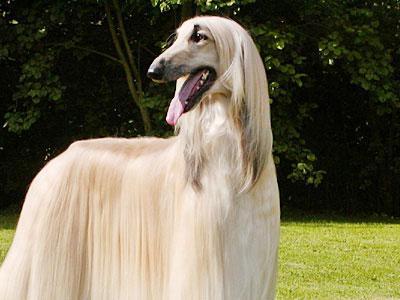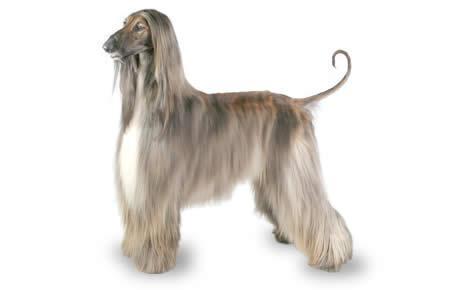The first image is the image on the left, the second image is the image on the right. Analyze the images presented: Is the assertion "The dog in both images are standing in the grass." valid? Answer yes or no. No. The first image is the image on the left, the second image is the image on the right. For the images displayed, is the sentence "Each image shows one blonde hound with long silky hair standing on a green grassy area." factually correct? Answer yes or no. No. The first image is the image on the left, the second image is the image on the right. Evaluate the accuracy of this statement regarding the images: "The dogs in the two images have their bodies turned toward each other, and their heads both turned in the same direction.". Is it true? Answer yes or no. Yes. The first image is the image on the left, the second image is the image on the right. Given the left and right images, does the statement "Both dogs are standing on a grassy area." hold true? Answer yes or no. No. 